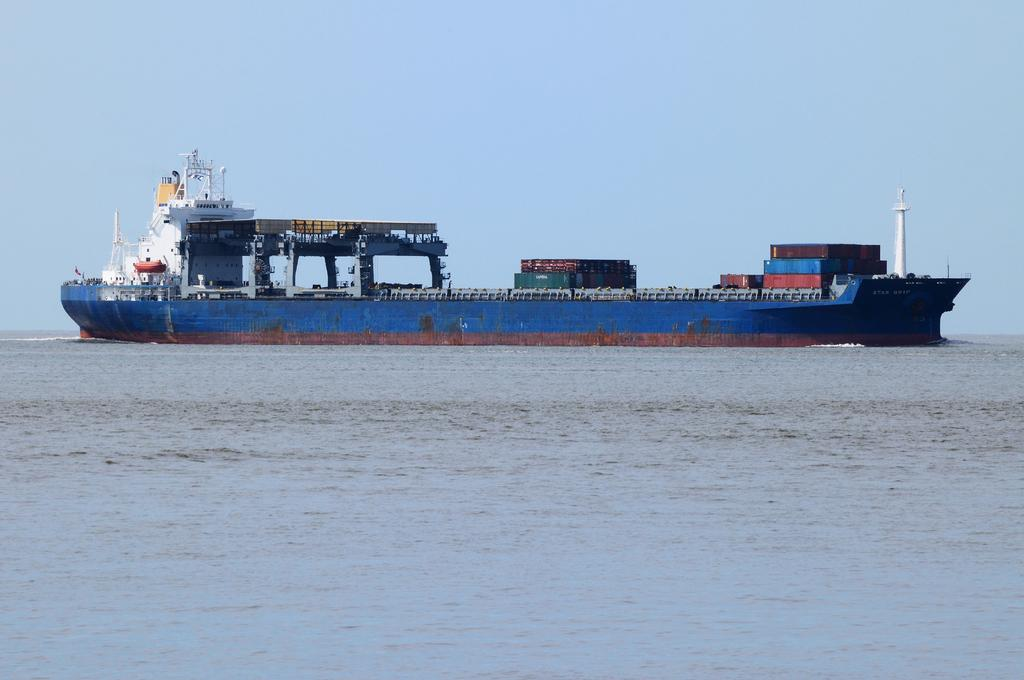What is the main subject of the image? There is a ship in the image. What color is the ship? The ship is blue in color. What is the ship doing in the image? The ship is moving on water. What can be seen in the background of the image? There is water visible in the image, and the sky is clear. How many legs can be seen supporting the ship in the image? There are no legs visible in the image, as ships are typically supported by water. What direction is the ship turning in the image? The image does not show the ship turning; it is moving forward on water. 